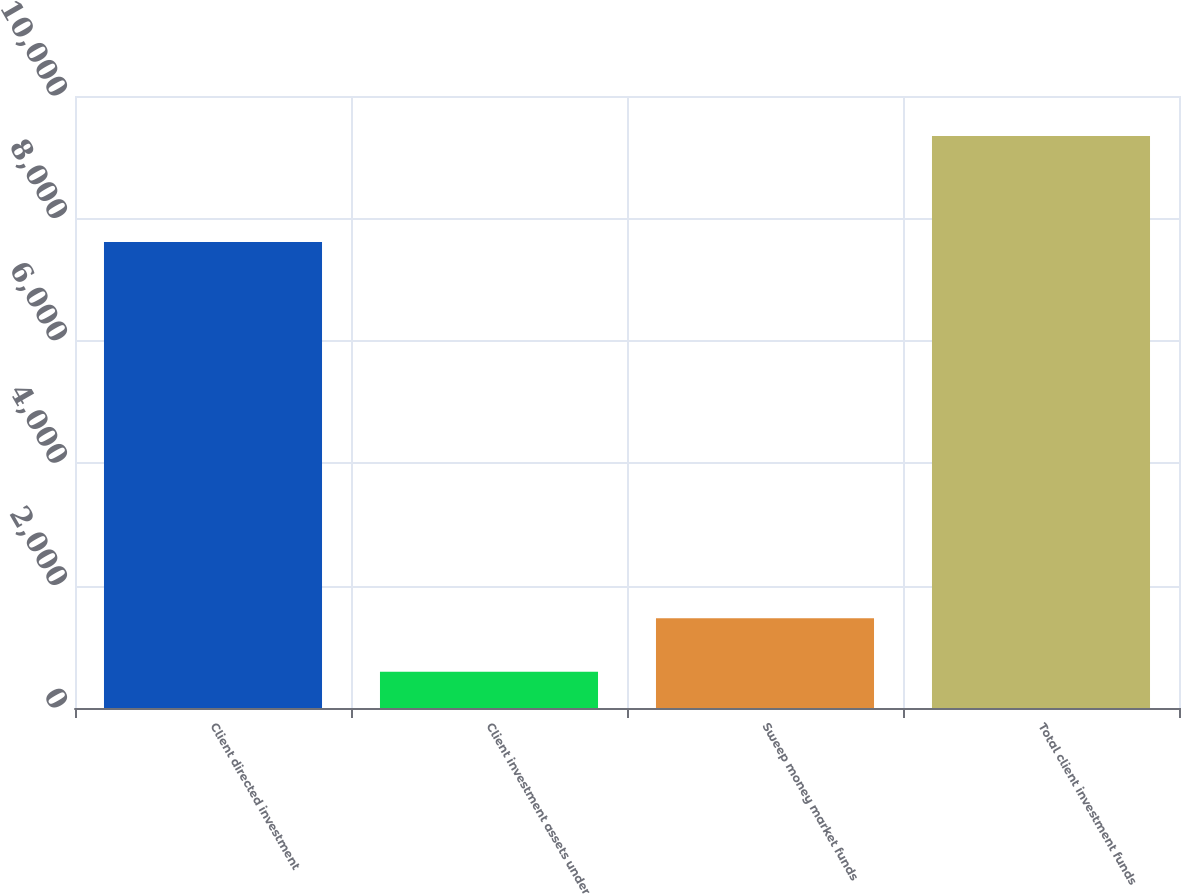<chart> <loc_0><loc_0><loc_500><loc_500><bar_chart><fcel>Client directed investment<fcel>Client investment assets under<fcel>Sweep money market funds<fcel>Total client investment funds<nl><fcel>7615<fcel>592<fcel>1467.4<fcel>9346<nl></chart> 